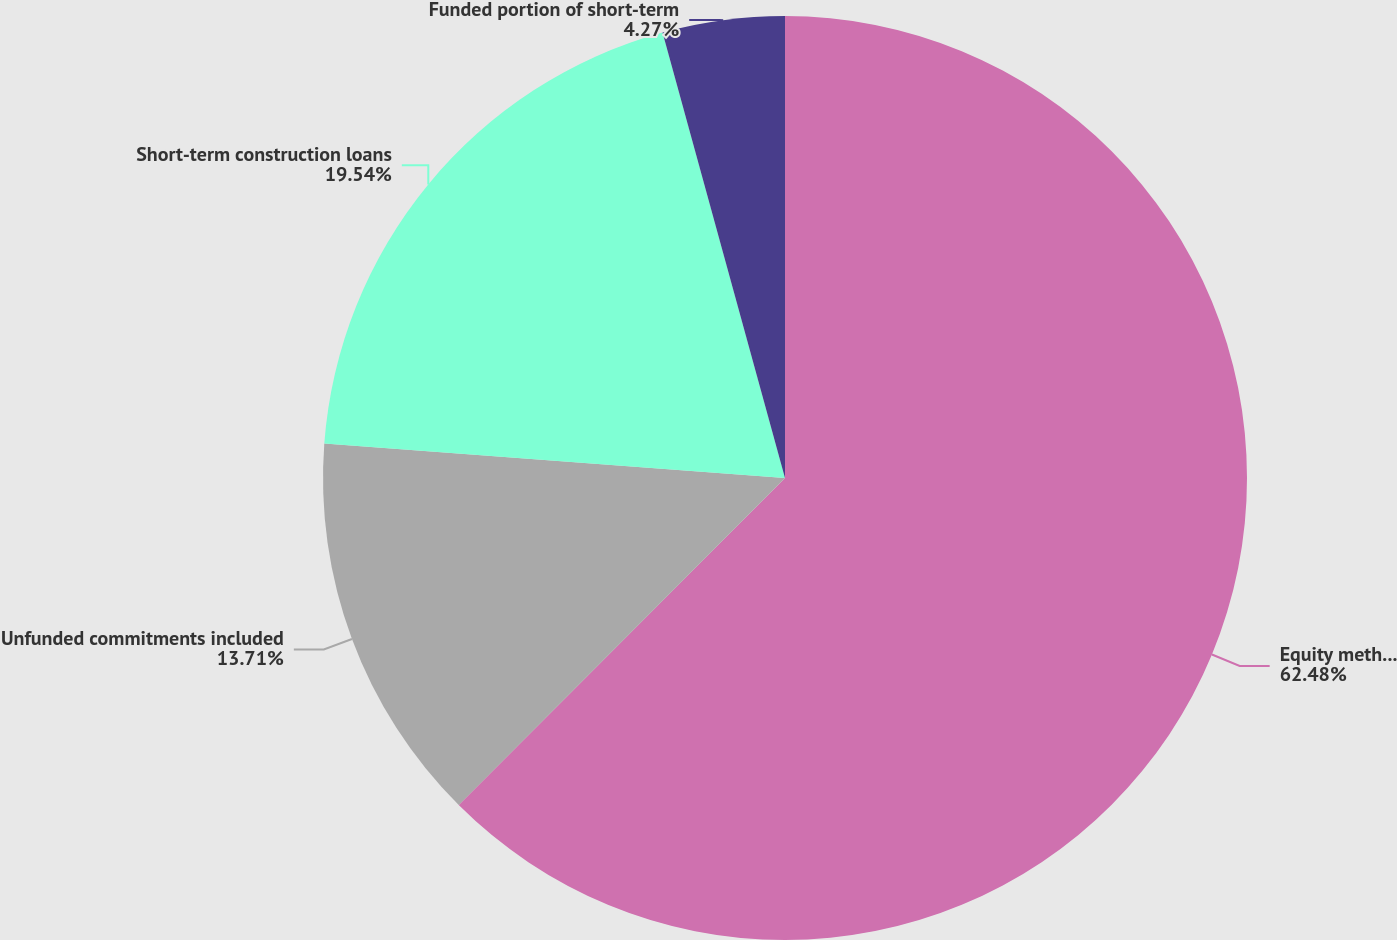Convert chart to OTSL. <chart><loc_0><loc_0><loc_500><loc_500><pie_chart><fcel>Equity method investments<fcel>Unfunded commitments included<fcel>Short-term construction loans<fcel>Funded portion of short-term<nl><fcel>62.48%<fcel>13.71%<fcel>19.54%<fcel>4.27%<nl></chart> 